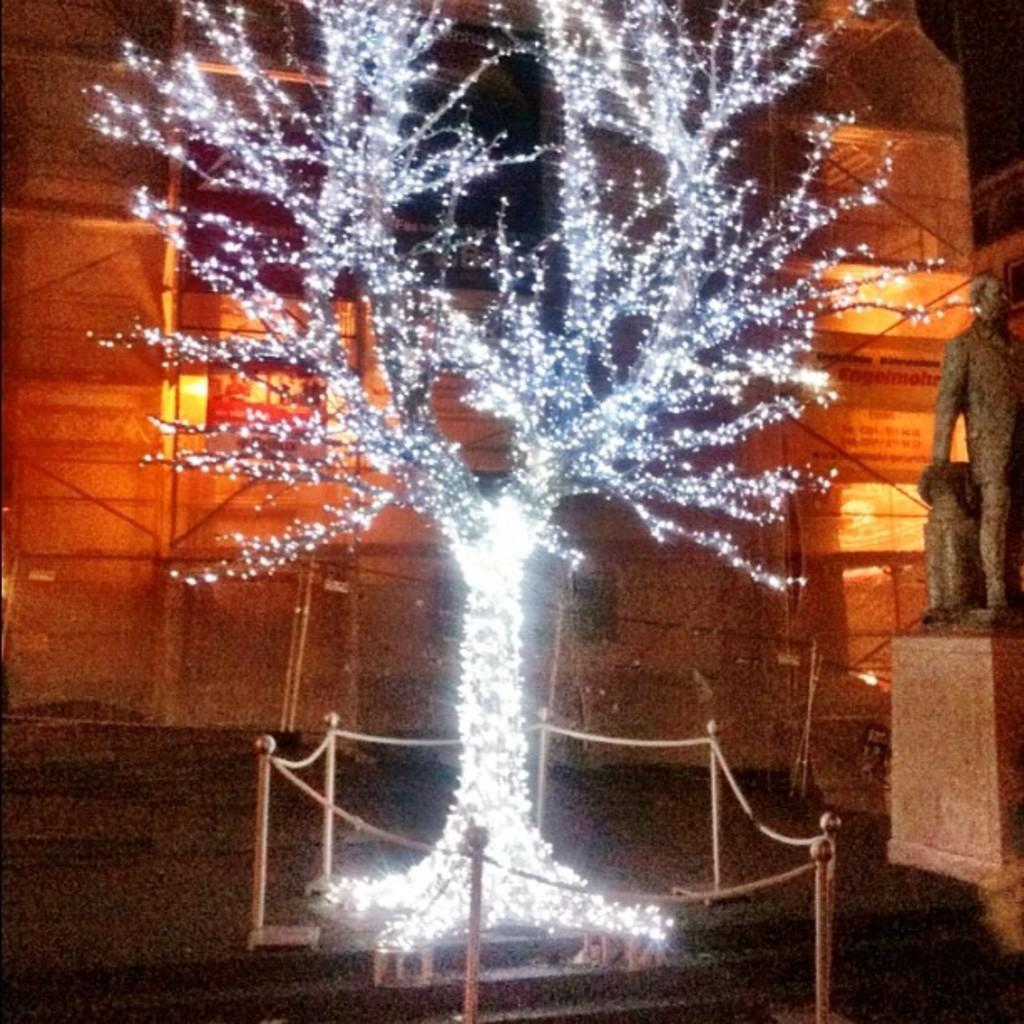What is present in the image that represents a natural element? There is a tree in the image. How is the tree in the image decorated? The tree is decorated with lights. What other object can be seen in the image besides the tree? There is a statue in the image. What can be seen in the background of the image? There is a building and lights visible in the background of the image. What type of clover is growing near the statue in the image? There is no clover present in the image; it only features a tree, a statue, and a building in the background. 